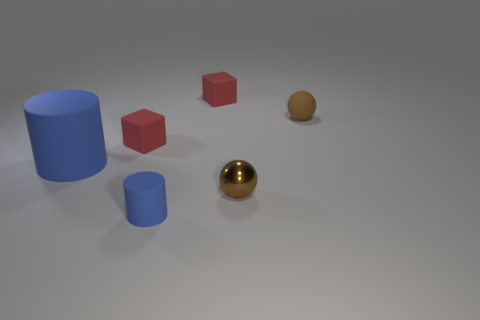Are there the same number of big blue cylinders that are behind the large blue cylinder and tiny objects to the left of the brown metallic thing?
Your answer should be compact. No. What material is the small thing that is in front of the big blue matte thing and on the left side of the small brown metallic sphere?
Your response must be concise. Rubber. There is a shiny thing; is it the same size as the red cube to the left of the tiny blue rubber thing?
Offer a very short reply. Yes. How many other things are the same color as the tiny cylinder?
Offer a very short reply. 1. Are there more tiny red matte objects in front of the brown metal thing than brown shiny cubes?
Provide a succinct answer. No. There is a small cylinder that is in front of the tiny brown rubber thing that is behind the matte block that is on the left side of the small blue object; what color is it?
Make the answer very short. Blue. Is the material of the big blue object the same as the small blue cylinder?
Your answer should be compact. Yes. Is there a metallic thing that has the same size as the brown metallic sphere?
Offer a very short reply. No. There is another ball that is the same size as the metal sphere; what material is it?
Provide a succinct answer. Rubber. Is there a brown rubber thing that has the same shape as the tiny blue rubber object?
Provide a succinct answer. No. 